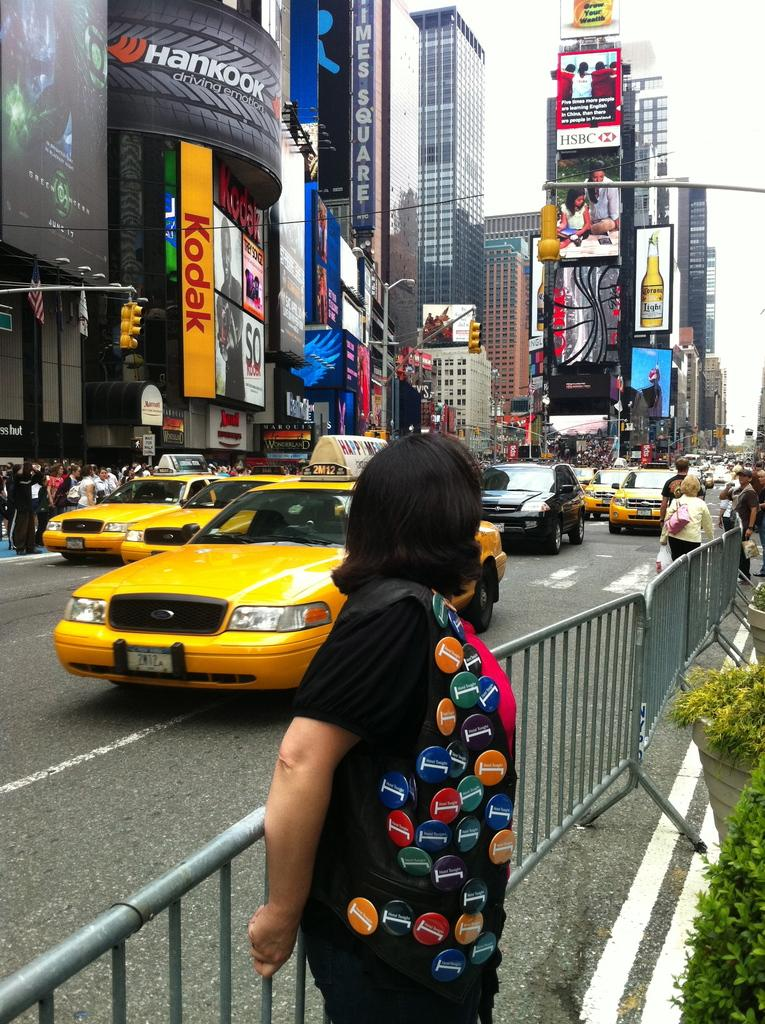<image>
Describe the image concisely. a Kodak sign that is next to a large street area' 